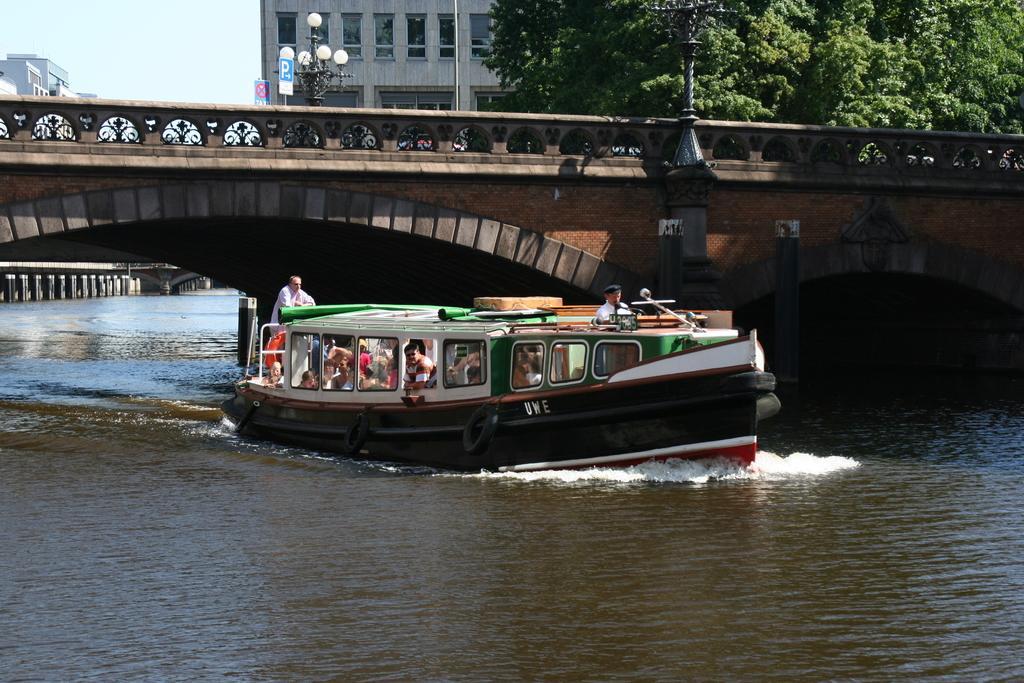Please provide a concise description of this image. In this picture there is a boat which has few people in it is on the water and there is a bridge above it and there are buildings and trees in the background. 